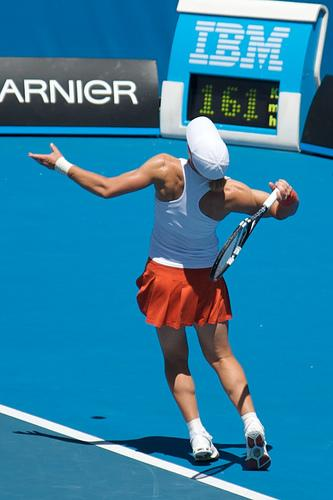What is the person doing? playing tennis 